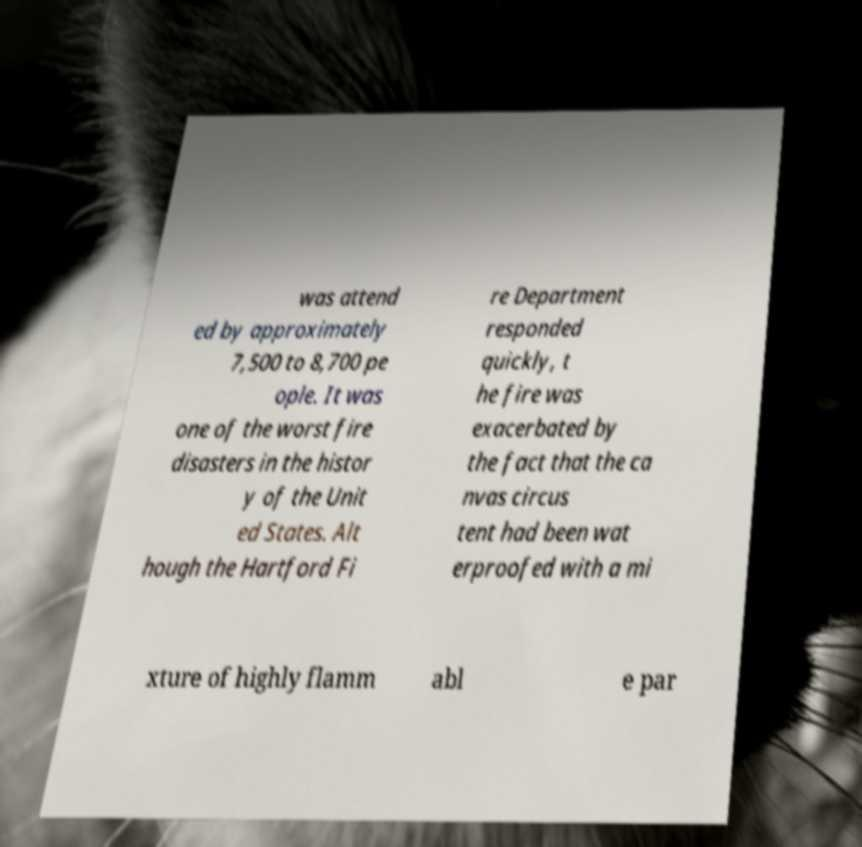What messages or text are displayed in this image? I need them in a readable, typed format. was attend ed by approximately 7,500 to 8,700 pe ople. It was one of the worst fire disasters in the histor y of the Unit ed States. Alt hough the Hartford Fi re Department responded quickly, t he fire was exacerbated by the fact that the ca nvas circus tent had been wat erproofed with a mi xture of highly flamm abl e par 